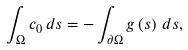<formula> <loc_0><loc_0><loc_500><loc_500>\int _ { \Omega } c _ { 0 } \, d s = - \int _ { \partial \Omega } g \left ( s \right ) \, d s ,</formula> 